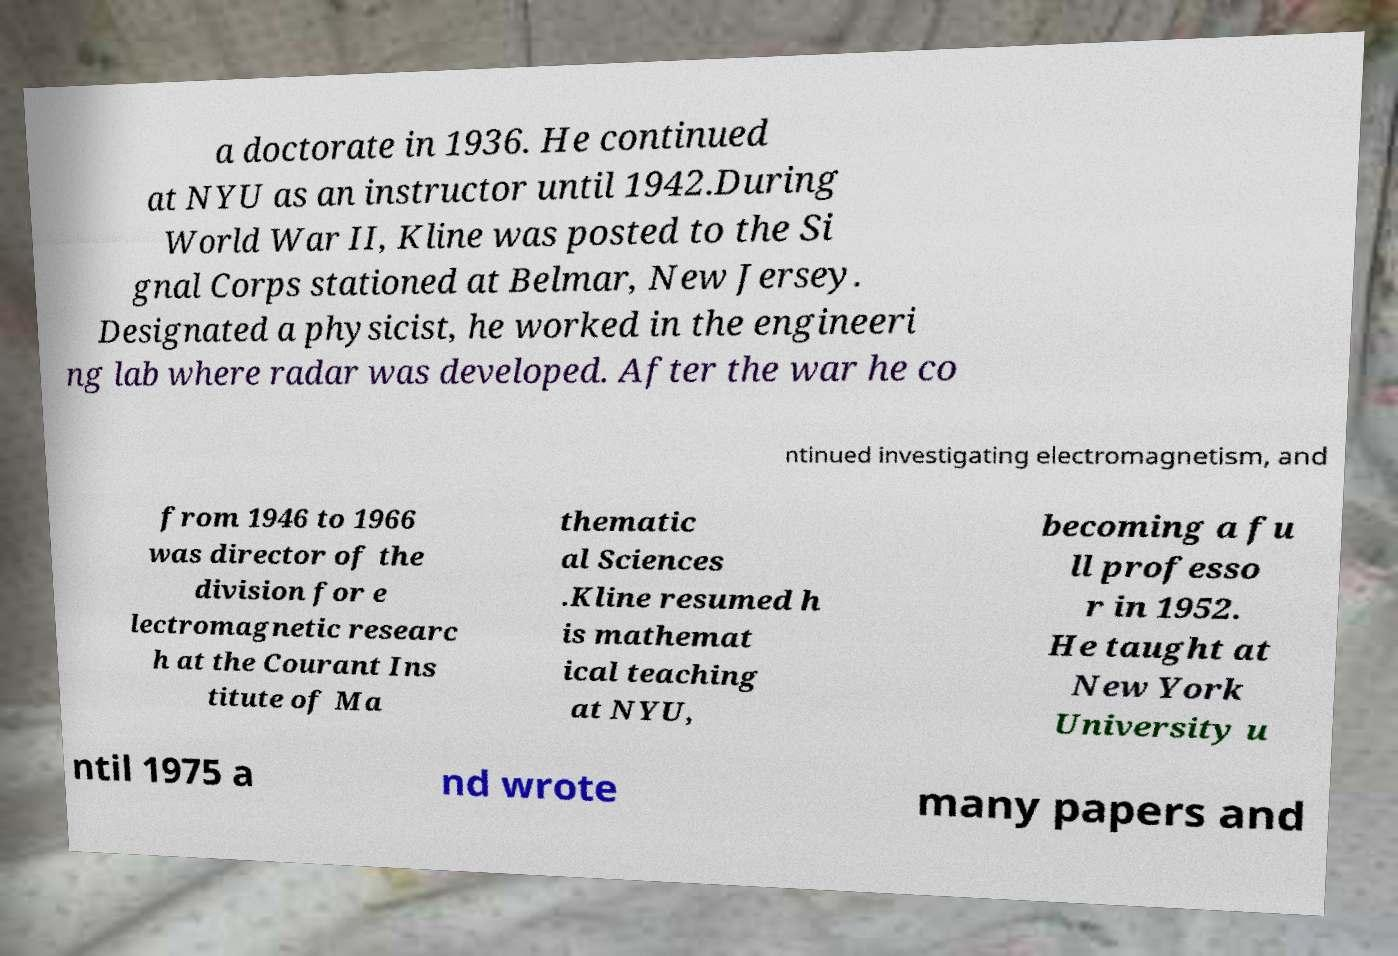Can you read and provide the text displayed in the image?This photo seems to have some interesting text. Can you extract and type it out for me? a doctorate in 1936. He continued at NYU as an instructor until 1942.During World War II, Kline was posted to the Si gnal Corps stationed at Belmar, New Jersey. Designated a physicist, he worked in the engineeri ng lab where radar was developed. After the war he co ntinued investigating electromagnetism, and from 1946 to 1966 was director of the division for e lectromagnetic researc h at the Courant Ins titute of Ma thematic al Sciences .Kline resumed h is mathemat ical teaching at NYU, becoming a fu ll professo r in 1952. He taught at New York University u ntil 1975 a nd wrote many papers and 